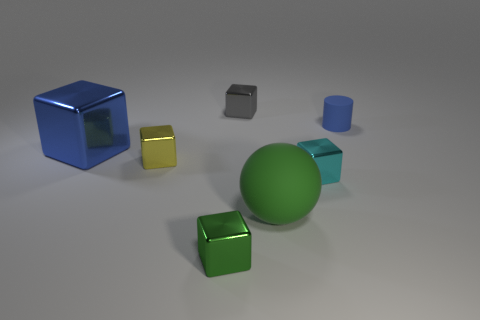Add 1 matte cubes. How many objects exist? 8 Subtract all yellow metal cubes. How many cubes are left? 4 Subtract all gray blocks. How many blocks are left? 4 Subtract all red cubes. Subtract all cyan cylinders. How many cubes are left? 5 Subtract all spheres. How many objects are left? 6 Add 3 gray metallic cubes. How many gray metallic cubes exist? 4 Subtract 0 red cubes. How many objects are left? 7 Subtract all cubes. Subtract all balls. How many objects are left? 1 Add 7 blue matte cylinders. How many blue matte cylinders are left? 8 